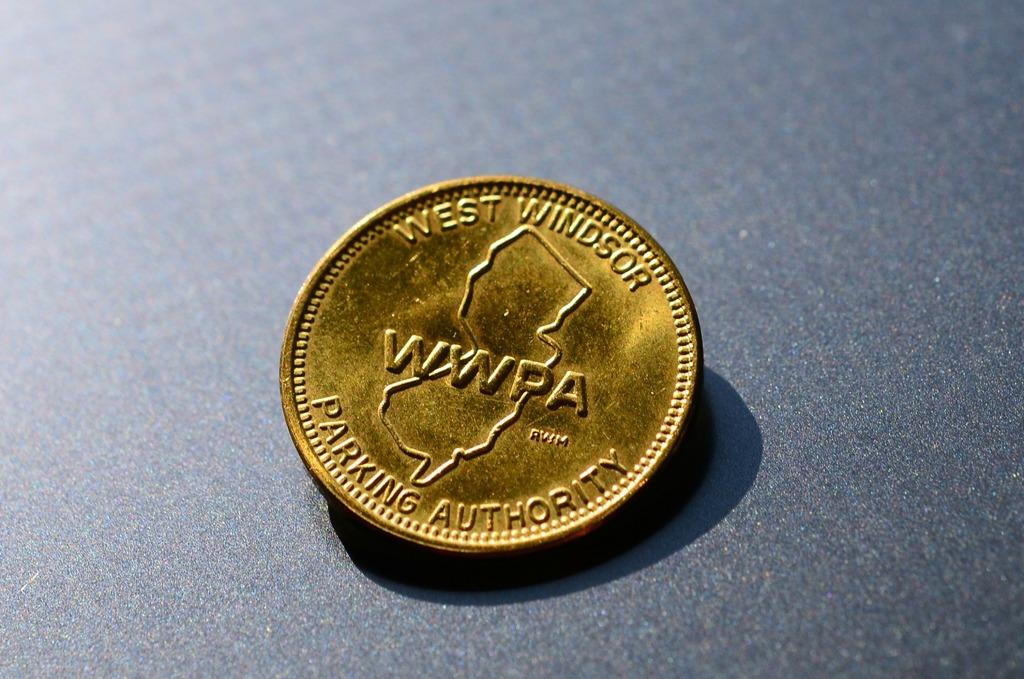Provide a one-sentence caption for the provided image. The gold coin is a particular coin for parking authority. 